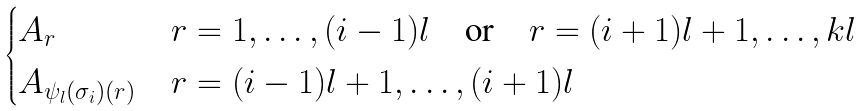<formula> <loc_0><loc_0><loc_500><loc_500>\begin{cases} A _ { r } & r = 1 , \dots , ( i - 1 ) l \quad \text {or} \quad r = ( i + 1 ) l + 1 , \dots , k l \\ A _ { \psi _ { l } ( \sigma _ { i } ) ( r ) } & r = ( i - 1 ) l + 1 , \dots , ( i + 1 ) l \\ \end{cases}</formula> 